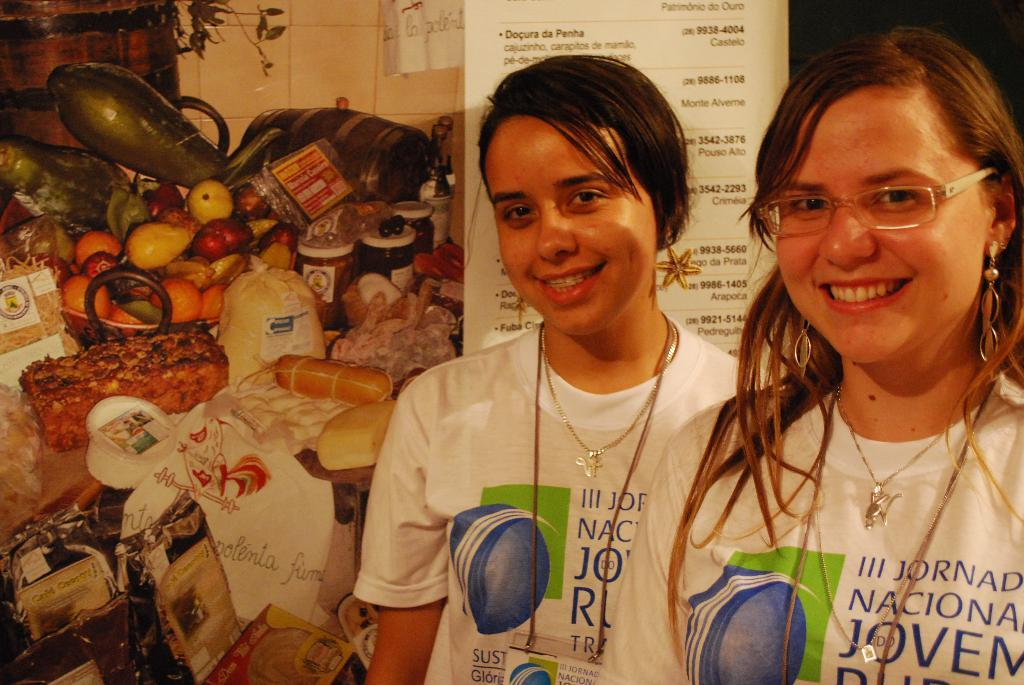How many people are in the image? There are two ladies standing in the image. What can be seen in the background of the image? There is a banner in the background of the image. What is written or depicted on the banner? There is text on the banner, and there are objects visible on the banner. Are there any cobwebs visible on the banner in the image? There is no mention of cobwebs in the provided facts, and therefore we cannot determine if any are present in the image. 